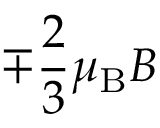<formula> <loc_0><loc_0><loc_500><loc_500>\mp { \frac { 2 } { 3 } } \mu _ { B } B</formula> 